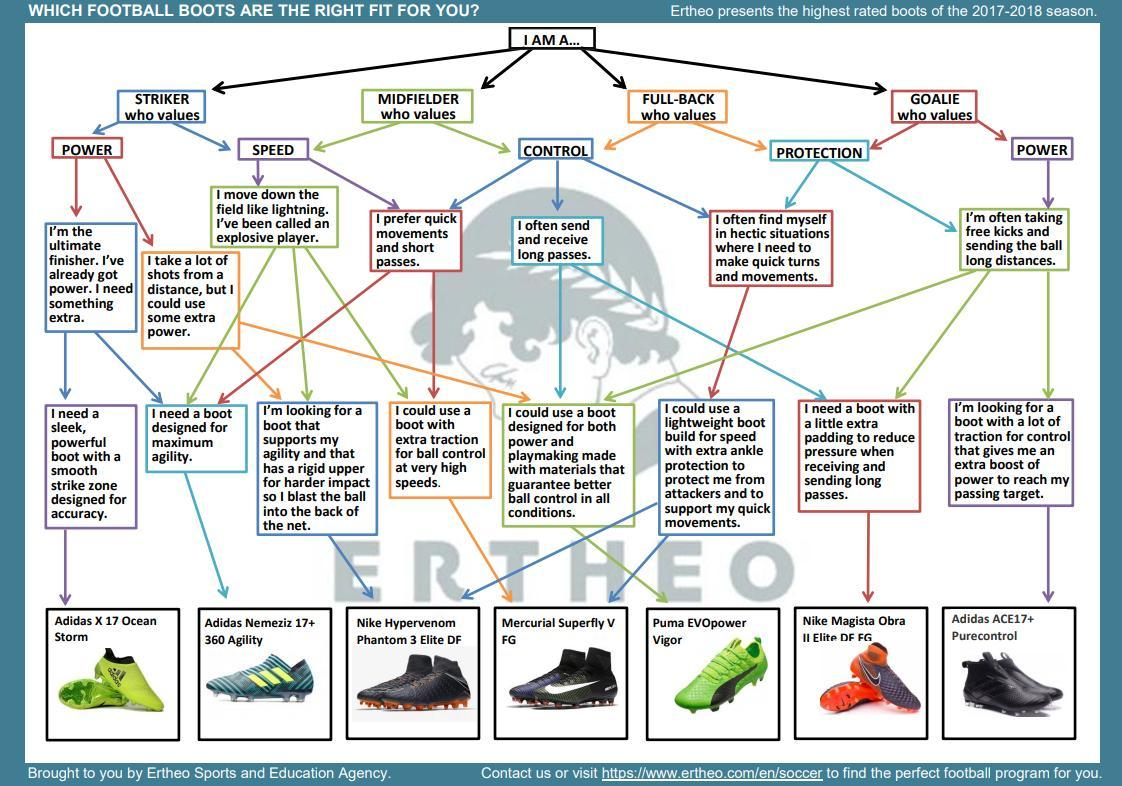Which boot is suitable for those wanting extra traction for ball control at very high speeds?
Answer the question with a short phrase. Mercurial Superfly V FG What are the brands of both green boots shown? Adidas, Puma What is Adidas Nemeziz 17+ 360 Agility designed for? designed for maximum agility How many football boots are shown? 7 How many green boots are shown? 2 Which boot has sleek, powerful features with smooth strike zone designed for accuracy? Adidas X 17 Ocean Storm What is the name of the orange coloured boot? Nike Magista Obra II Elite DF FG 